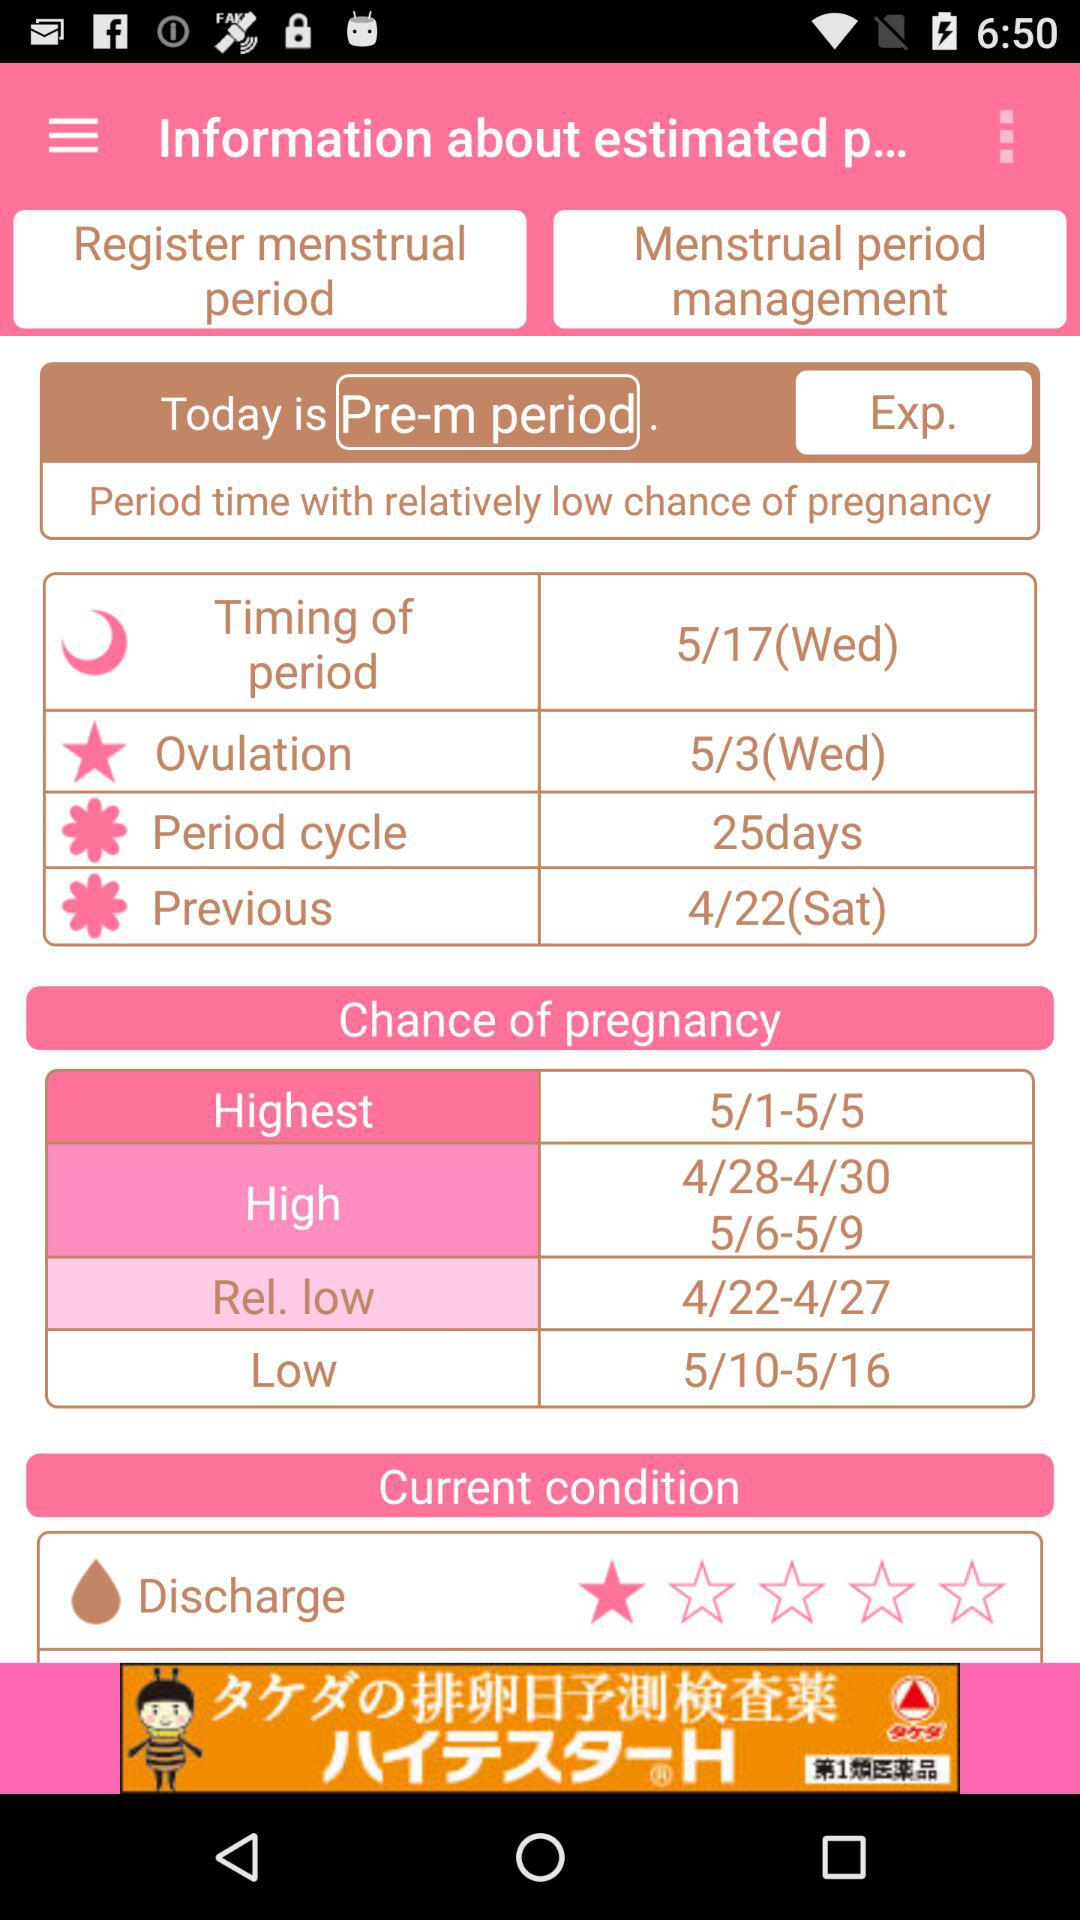What is the highest chance of pregnanacy? The highest chance of pregnancy is 5 / 1-5 / 5. 